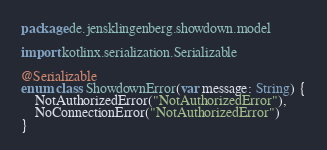<code> <loc_0><loc_0><loc_500><loc_500><_Kotlin_>package de.jensklingenberg.showdown.model

import kotlinx.serialization.Serializable

@Serializable
enum class ShowdownError(var message: String) {
    NotAuthorizedError("NotAuthorizedError"),
    NoConnectionError("NotAuthorizedError")
}</code> 